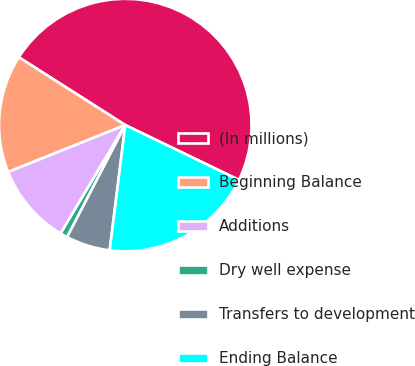<chart> <loc_0><loc_0><loc_500><loc_500><pie_chart><fcel>(In millions)<fcel>Beginning Balance<fcel>Additions<fcel>Dry well expense<fcel>Transfers to development<fcel>Ending Balance<nl><fcel>48.13%<fcel>15.09%<fcel>10.37%<fcel>0.94%<fcel>5.65%<fcel>19.81%<nl></chart> 